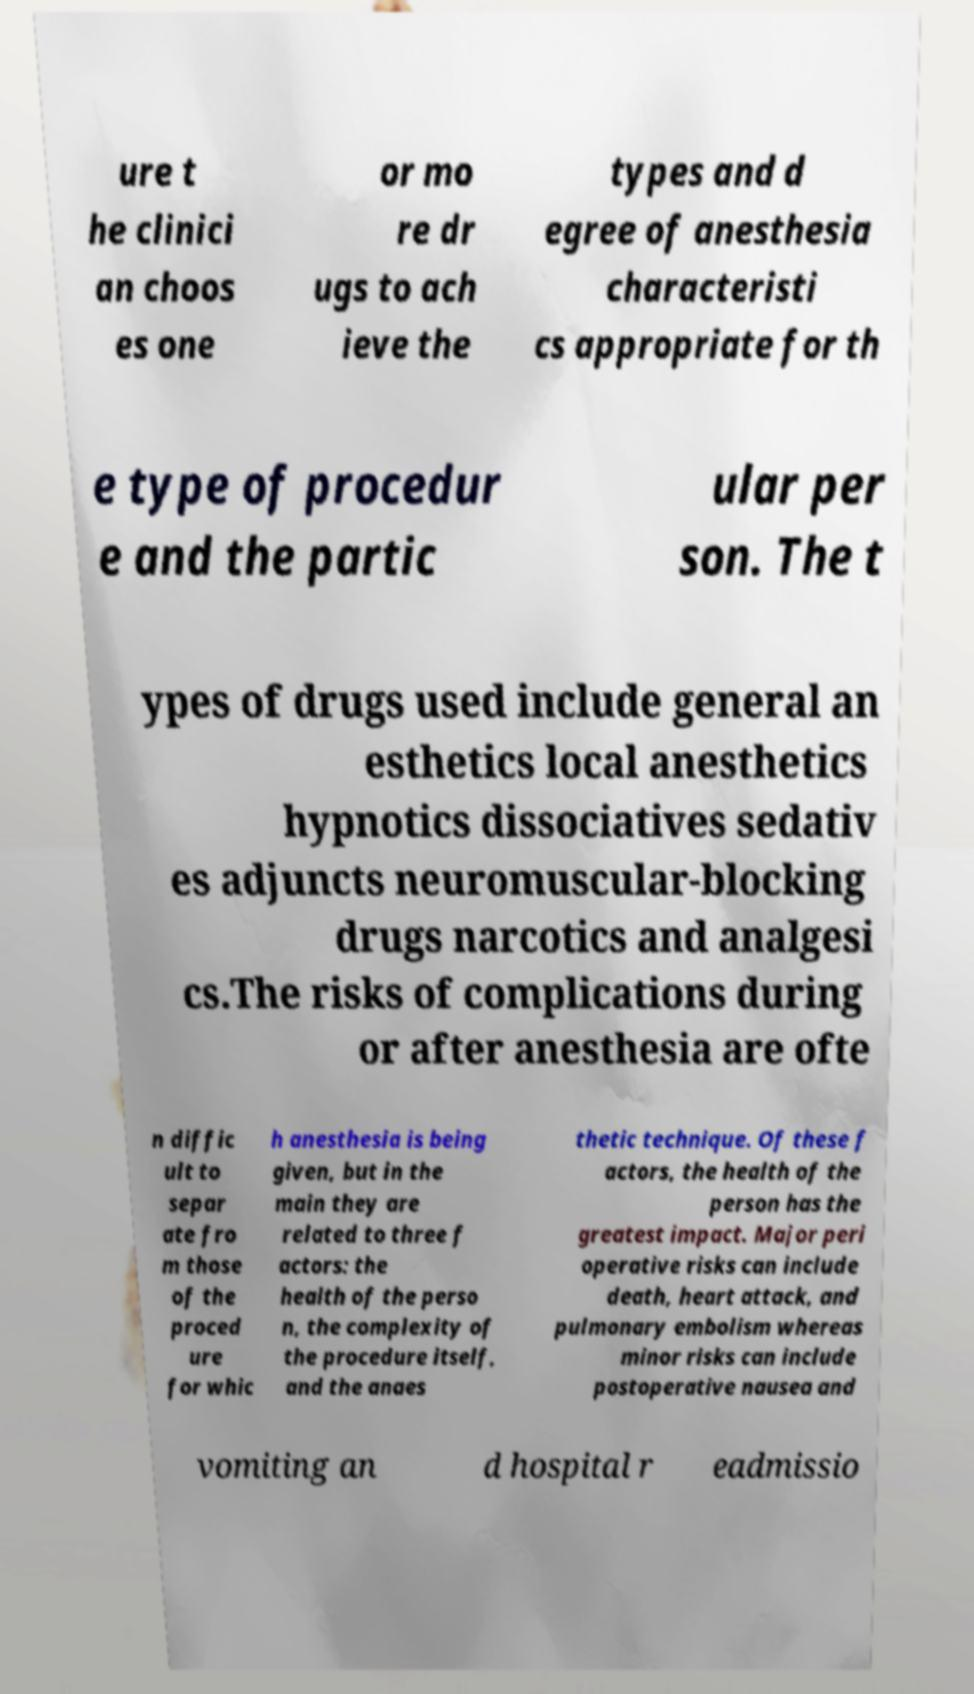Can you accurately transcribe the text from the provided image for me? ure t he clinici an choos es one or mo re dr ugs to ach ieve the types and d egree of anesthesia characteristi cs appropriate for th e type of procedur e and the partic ular per son. The t ypes of drugs used include general an esthetics local anesthetics hypnotics dissociatives sedativ es adjuncts neuromuscular-blocking drugs narcotics and analgesi cs.The risks of complications during or after anesthesia are ofte n diffic ult to separ ate fro m those of the proced ure for whic h anesthesia is being given, but in the main they are related to three f actors: the health of the perso n, the complexity of the procedure itself, and the anaes thetic technique. Of these f actors, the health of the person has the greatest impact. Major peri operative risks can include death, heart attack, and pulmonary embolism whereas minor risks can include postoperative nausea and vomiting an d hospital r eadmissio 